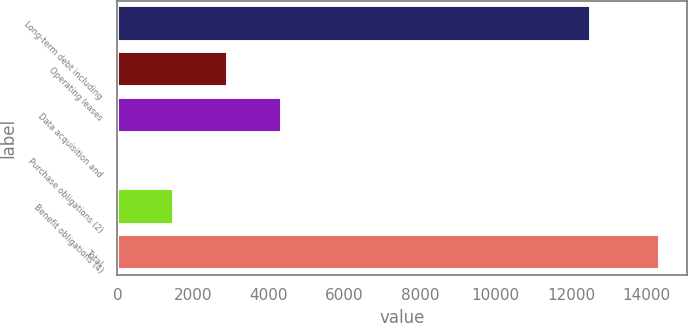Convert chart. <chart><loc_0><loc_0><loc_500><loc_500><bar_chart><fcel>Long-term debt including<fcel>Operating leases<fcel>Data acquisition and<fcel>Purchase obligations (2)<fcel>Benefit obligations (4)<fcel>Total<nl><fcel>12512<fcel>2930.4<fcel>4357.1<fcel>77<fcel>1503.7<fcel>14344<nl></chart> 